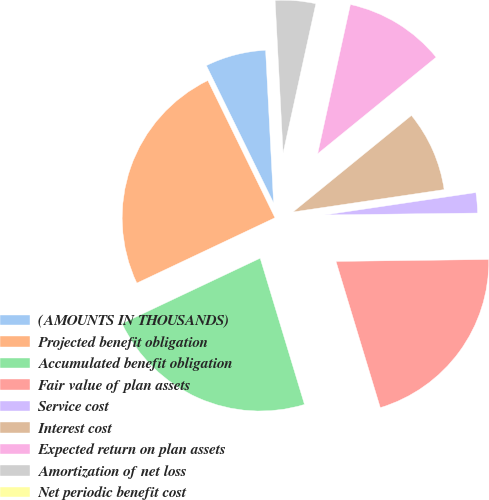<chart> <loc_0><loc_0><loc_500><loc_500><pie_chart><fcel>(AMOUNTS IN THOUSANDS)<fcel>Projected benefit obligation<fcel>Accumulated benefit obligation<fcel>Fair value of plan assets<fcel>Service cost<fcel>Interest cost<fcel>Expected return on plan assets<fcel>Amortization of net loss<fcel>Net periodic benefit cost<nl><fcel>6.41%<fcel>24.79%<fcel>22.65%<fcel>20.52%<fcel>2.14%<fcel>8.54%<fcel>10.68%<fcel>4.27%<fcel>0.0%<nl></chart> 